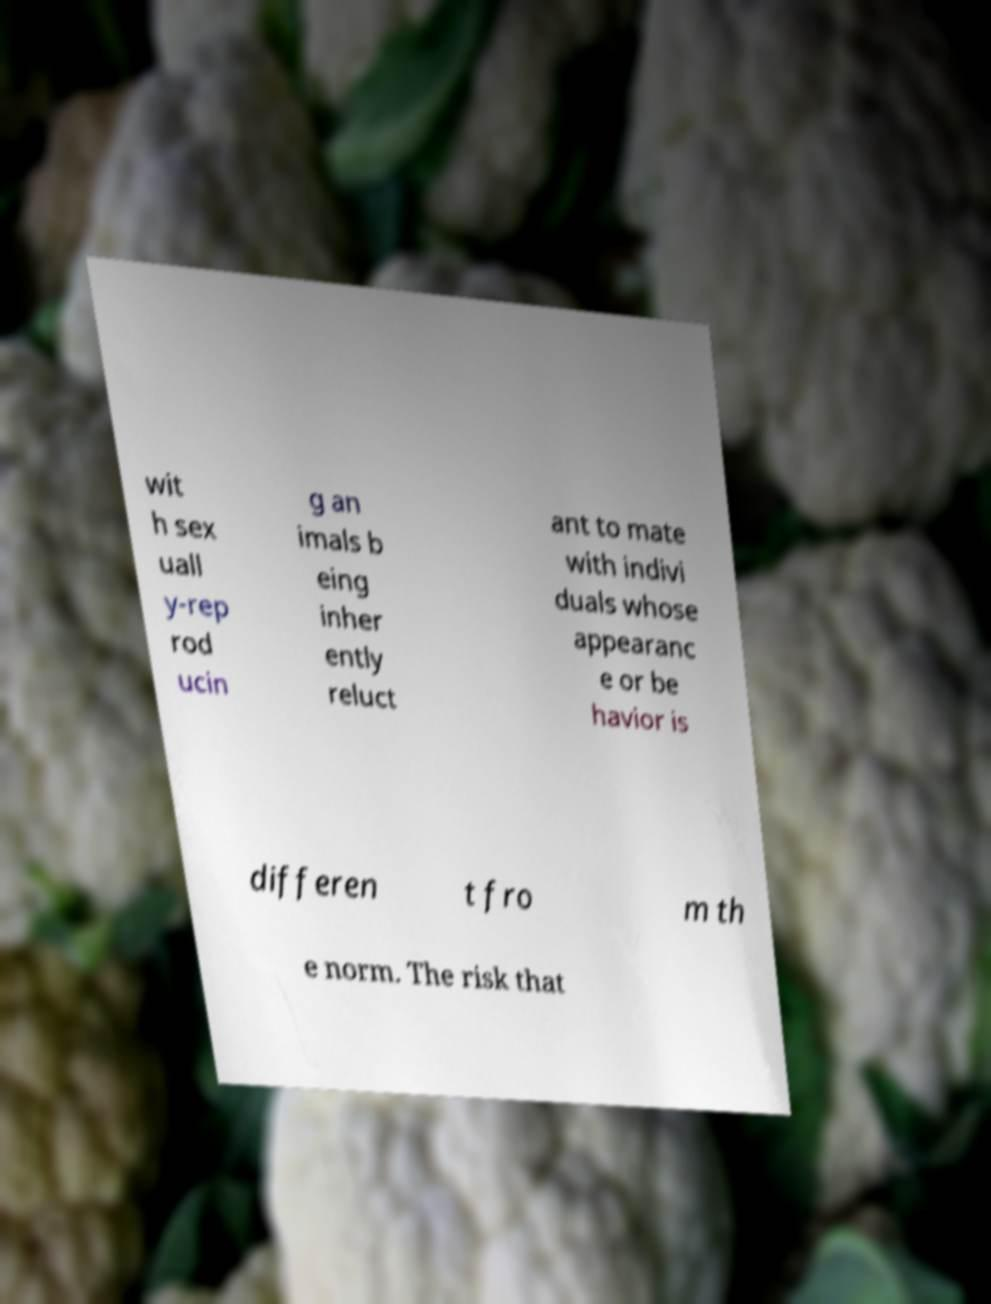Could you extract and type out the text from this image? wit h sex uall y-rep rod ucin g an imals b eing inher ently reluct ant to mate with indivi duals whose appearanc e or be havior is differen t fro m th e norm. The risk that 